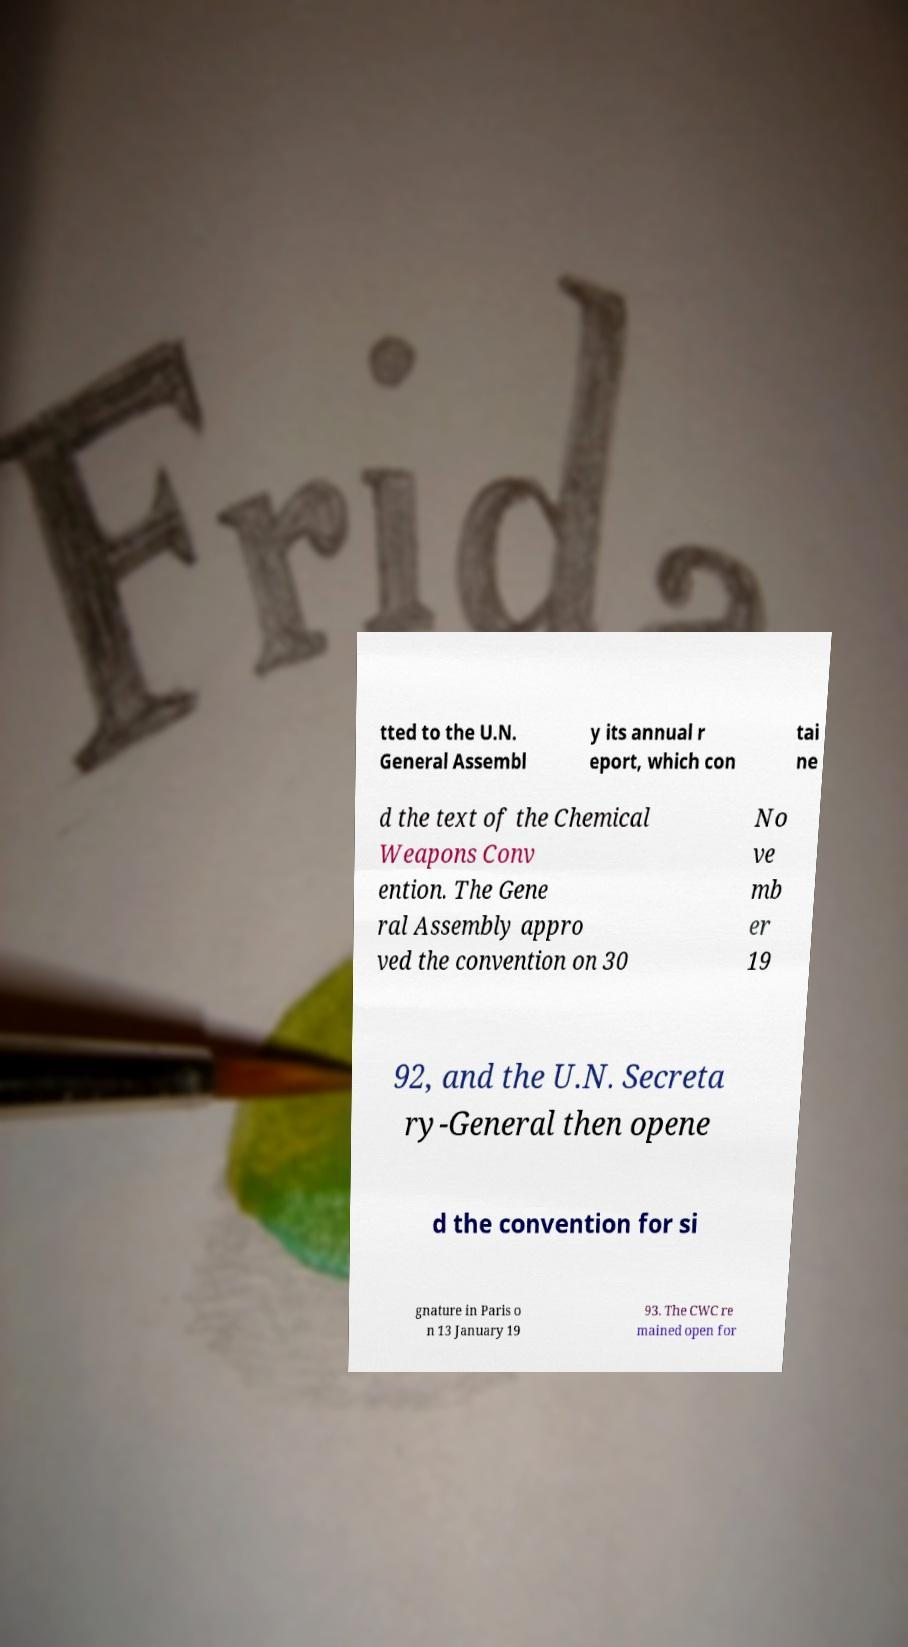I need the written content from this picture converted into text. Can you do that? tted to the U.N. General Assembl y its annual r eport, which con tai ne d the text of the Chemical Weapons Conv ention. The Gene ral Assembly appro ved the convention on 30 No ve mb er 19 92, and the U.N. Secreta ry-General then opene d the convention for si gnature in Paris o n 13 January 19 93. The CWC re mained open for 